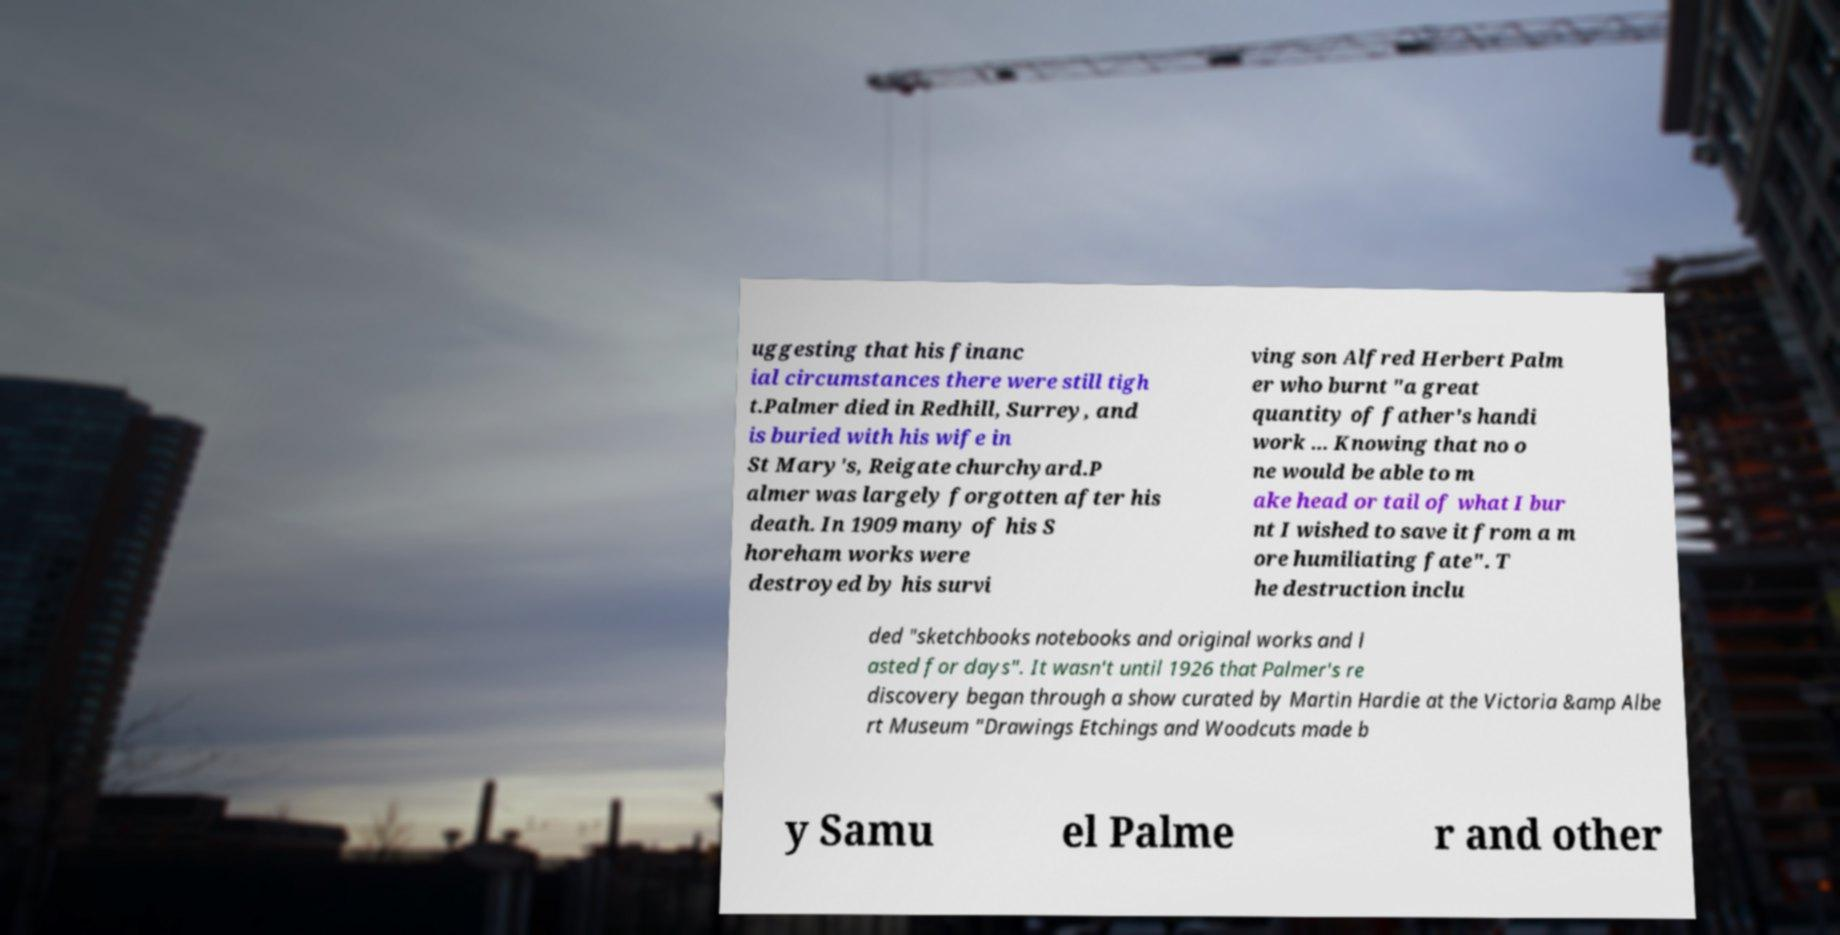What messages or text are displayed in this image? I need them in a readable, typed format. uggesting that his financ ial circumstances there were still tigh t.Palmer died in Redhill, Surrey, and is buried with his wife in St Mary's, Reigate churchyard.P almer was largely forgotten after his death. In 1909 many of his S horeham works were destroyed by his survi ving son Alfred Herbert Palm er who burnt "a great quantity of father's handi work ... Knowing that no o ne would be able to m ake head or tail of what I bur nt I wished to save it from a m ore humiliating fate". T he destruction inclu ded "sketchbooks notebooks and original works and l asted for days". It wasn't until 1926 that Palmer's re discovery began through a show curated by Martin Hardie at the Victoria &amp Albe rt Museum "Drawings Etchings and Woodcuts made b y Samu el Palme r and other 